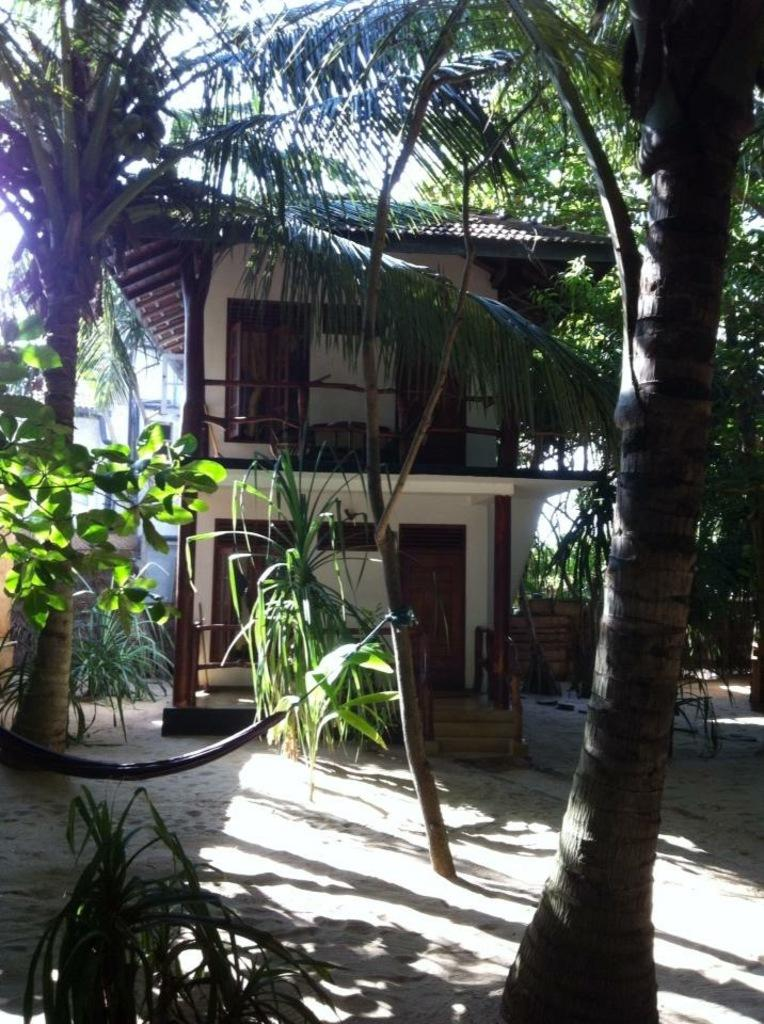What type of structure is present in the image? There is a building in the image. What features can be seen on the building? The building has doors, windows, and stairs. What type of vegetation is present in the image? There are trees and plants in the image. What is visible on the ground in the image? There are objects on the ground in the image. What can be seen in the sky in the image? The sky is visible in the image. What is the weight of the spot on the building in the image? There is no spot on the building in the image, so it is not possible to determine its weight. 